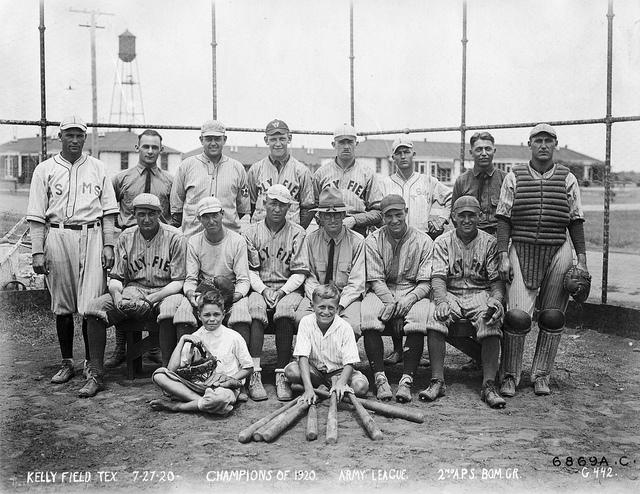What role does the most heavily armored person shown here hold? Please explain your reasoning. catcher. He's a catcher. 